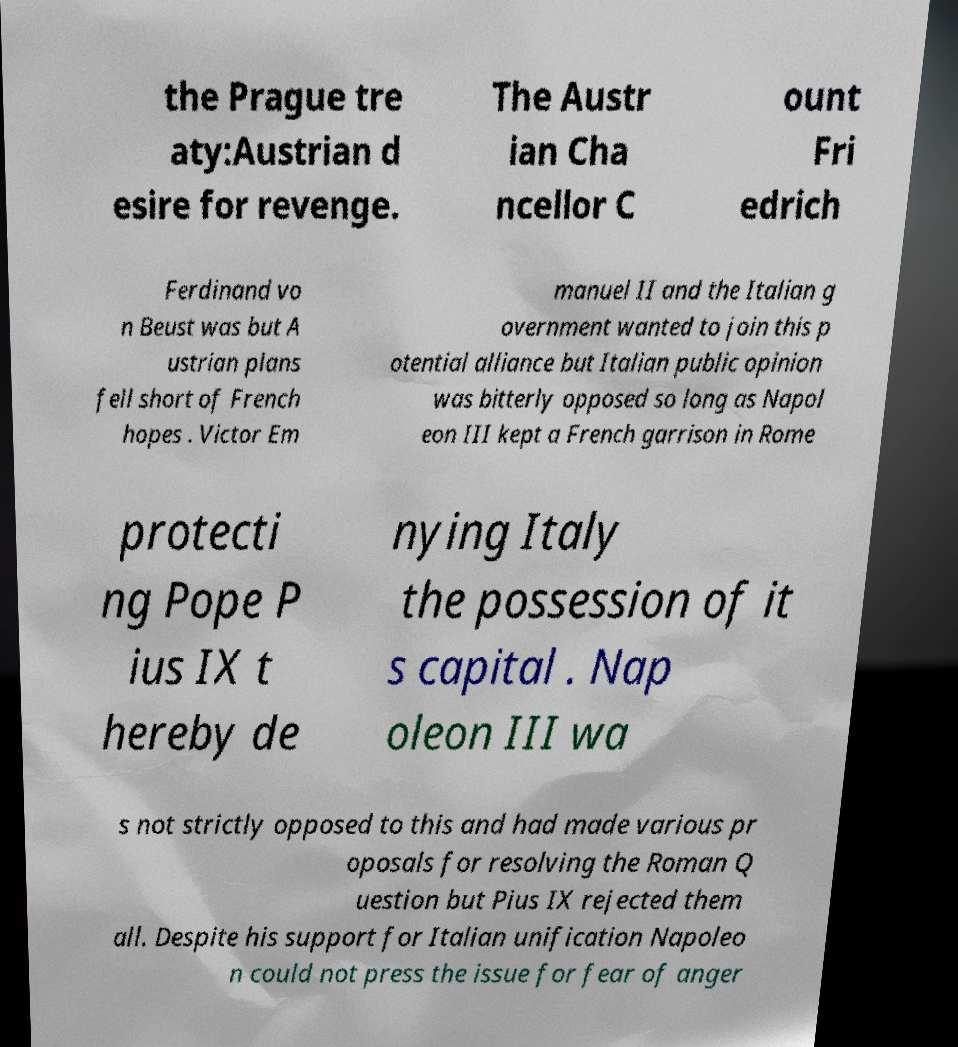Please read and relay the text visible in this image. What does it say? the Prague tre aty:Austrian d esire for revenge. The Austr ian Cha ncellor C ount Fri edrich Ferdinand vo n Beust was but A ustrian plans fell short of French hopes . Victor Em manuel II and the Italian g overnment wanted to join this p otential alliance but Italian public opinion was bitterly opposed so long as Napol eon III kept a French garrison in Rome protecti ng Pope P ius IX t hereby de nying Italy the possession of it s capital . Nap oleon III wa s not strictly opposed to this and had made various pr oposals for resolving the Roman Q uestion but Pius IX rejected them all. Despite his support for Italian unification Napoleo n could not press the issue for fear of anger 